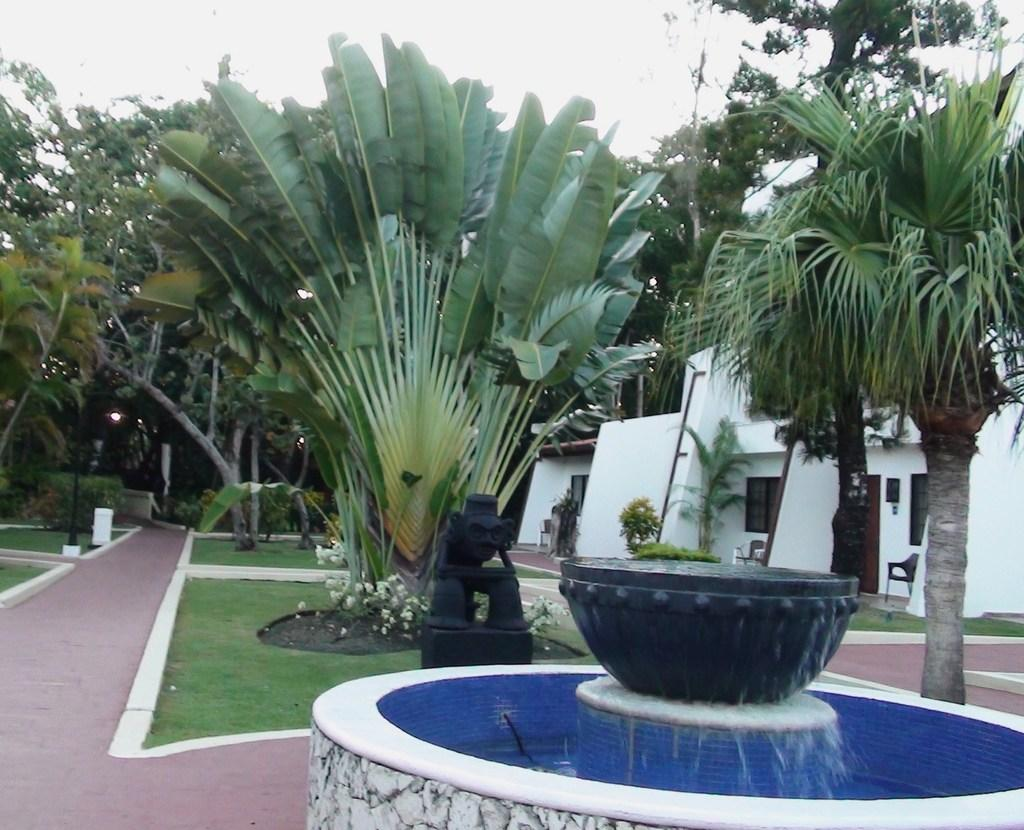What is the main feature in the image? There is a fountain in the image. What type of vegetation is present in the image? There is grass, plants, and trees in the image. What other objects can be seen in the image? There is a sculpture, chairs, and houses in the image. What is the condition of the water in the image? There is water visible in the image. What can be seen in the background of the image? The sky is visible in the background of the image. What type of shoe is the sister wearing in the image? There is no sister or shoe present in the image. What discovery was made at the fountain in the image? There is no discovery mentioned or depicted in the image. 